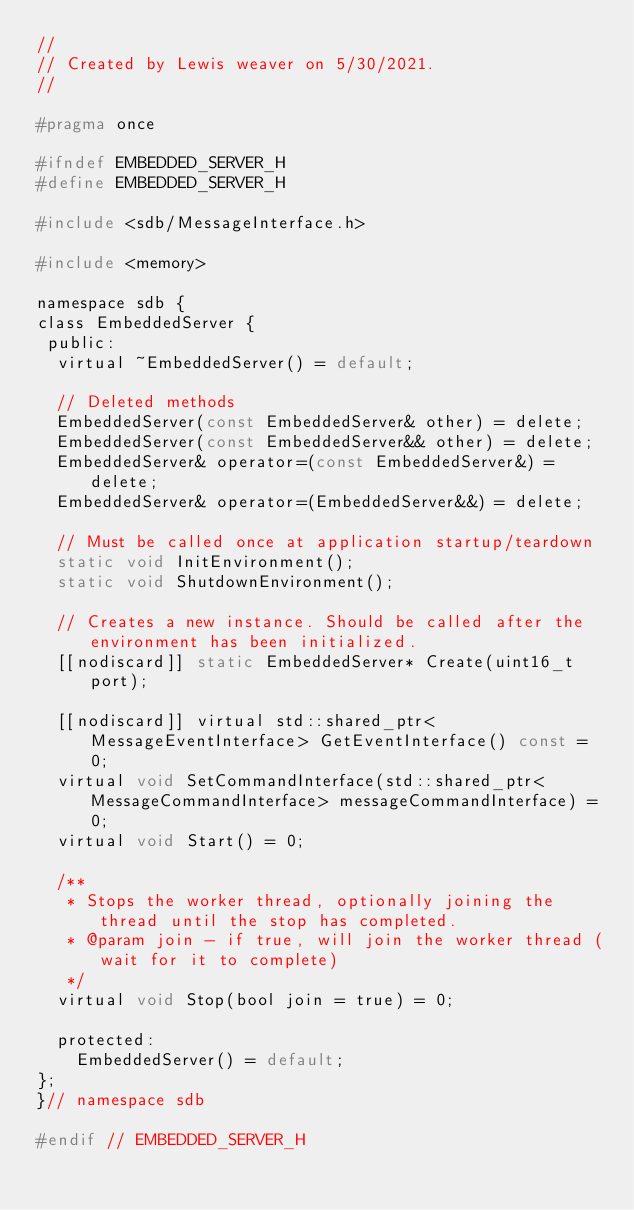<code> <loc_0><loc_0><loc_500><loc_500><_C_>//
// Created by Lewis weaver on 5/30/2021.
//

#pragma once

#ifndef EMBEDDED_SERVER_H
#define EMBEDDED_SERVER_H

#include <sdb/MessageInterface.h>

#include <memory>

namespace sdb {
class EmbeddedServer {
 public:
  virtual ~EmbeddedServer() = default;

  // Deleted methods
  EmbeddedServer(const EmbeddedServer& other) = delete;
  EmbeddedServer(const EmbeddedServer&& other) = delete;
  EmbeddedServer& operator=(const EmbeddedServer&) = delete;
  EmbeddedServer& operator=(EmbeddedServer&&) = delete;

  // Must be called once at application startup/teardown
  static void InitEnvironment();
  static void ShutdownEnvironment();

  // Creates a new instance. Should be called after the environment has been initialized.
  [[nodiscard]] static EmbeddedServer* Create(uint16_t port);

  [[nodiscard]] virtual std::shared_ptr<MessageEventInterface> GetEventInterface() const = 0;
  virtual void SetCommandInterface(std::shared_ptr<MessageCommandInterface> messageCommandInterface) = 0;
  virtual void Start() = 0;

  /**
   * Stops the worker thread, optionally joining the thread until the stop has completed.
   * @param join - if true, will join the worker thread (wait for it to complete)
   */
  virtual void Stop(bool join = true) = 0;

  protected: 
    EmbeddedServer() = default;
};
}// namespace sdb

#endif // EMBEDDED_SERVER_H
</code> 